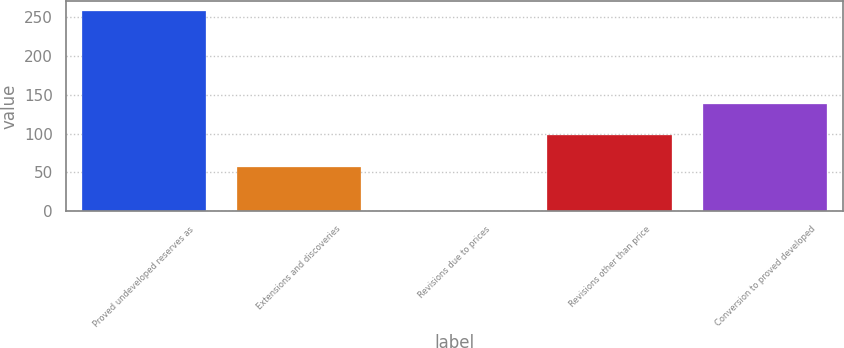Convert chart to OTSL. <chart><loc_0><loc_0><loc_500><loc_500><bar_chart><fcel>Proved undeveloped reserves as<fcel>Extensions and discoveries<fcel>Revisions due to prices<fcel>Revisions other than price<fcel>Conversion to proved developed<nl><fcel>258<fcel>57<fcel>1<fcel>97.6<fcel>138.2<nl></chart> 